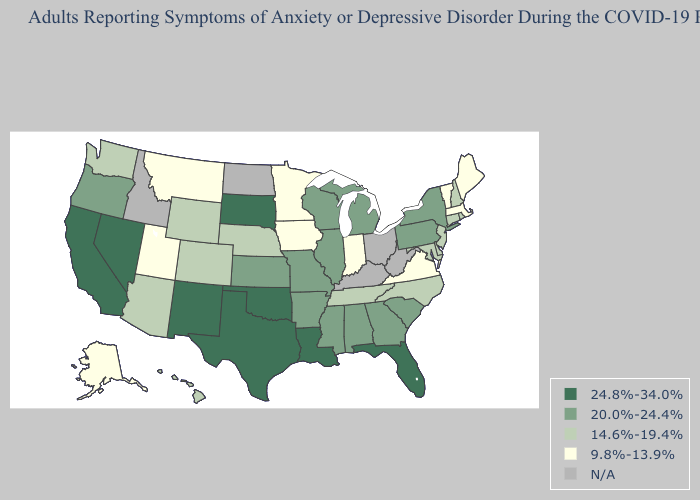What is the value of Georgia?
Be succinct. 20.0%-24.4%. What is the lowest value in the Northeast?
Answer briefly. 9.8%-13.9%. What is the value of Montana?
Keep it brief. 9.8%-13.9%. Which states hav the highest value in the Northeast?
Quick response, please. New York, Pennsylvania. What is the lowest value in the South?
Quick response, please. 9.8%-13.9%. How many symbols are there in the legend?
Concise answer only. 5. What is the lowest value in the Northeast?
Be succinct. 9.8%-13.9%. What is the lowest value in the USA?
Keep it brief. 9.8%-13.9%. How many symbols are there in the legend?
Short answer required. 5. Name the states that have a value in the range 24.8%-34.0%?
Give a very brief answer. California, Florida, Louisiana, Nevada, New Mexico, Oklahoma, South Dakota, Texas. Name the states that have a value in the range 9.8%-13.9%?
Quick response, please. Alaska, Indiana, Iowa, Maine, Massachusetts, Minnesota, Montana, Utah, Vermont, Virginia. Among the states that border Ohio , does Indiana have the lowest value?
Short answer required. Yes. What is the value of Vermont?
Give a very brief answer. 9.8%-13.9%. Name the states that have a value in the range 14.6%-19.4%?
Give a very brief answer. Arizona, Colorado, Connecticut, Delaware, Hawaii, Maryland, Nebraska, New Hampshire, New Jersey, North Carolina, Rhode Island, Tennessee, Washington, Wyoming. 